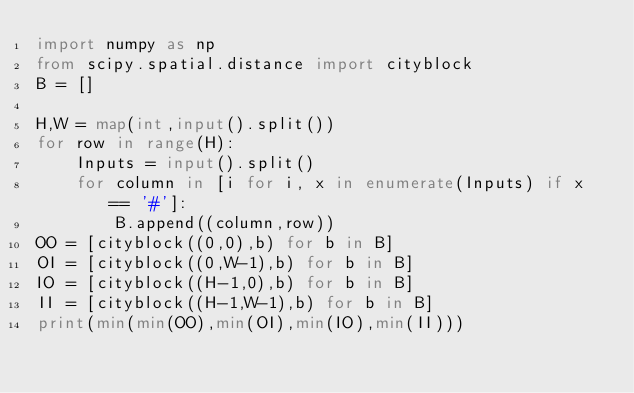Convert code to text. <code><loc_0><loc_0><loc_500><loc_500><_Python_>import numpy as np
from scipy.spatial.distance import cityblock
B = []

H,W = map(int,input().split())
for row in range(H):
    Inputs = input().split()
    for column in [i for i, x in enumerate(Inputs) if x == '#']:
        B.append((column,row))
OO = [cityblock((0,0),b) for b in B]
OI = [cityblock((0,W-1),b) for b in B]
IO = [cityblock((H-1,0),b) for b in B]
II = [cityblock((H-1,W-1),b) for b in B]
print(min(min(OO),min(OI),min(IO),min(II)))</code> 